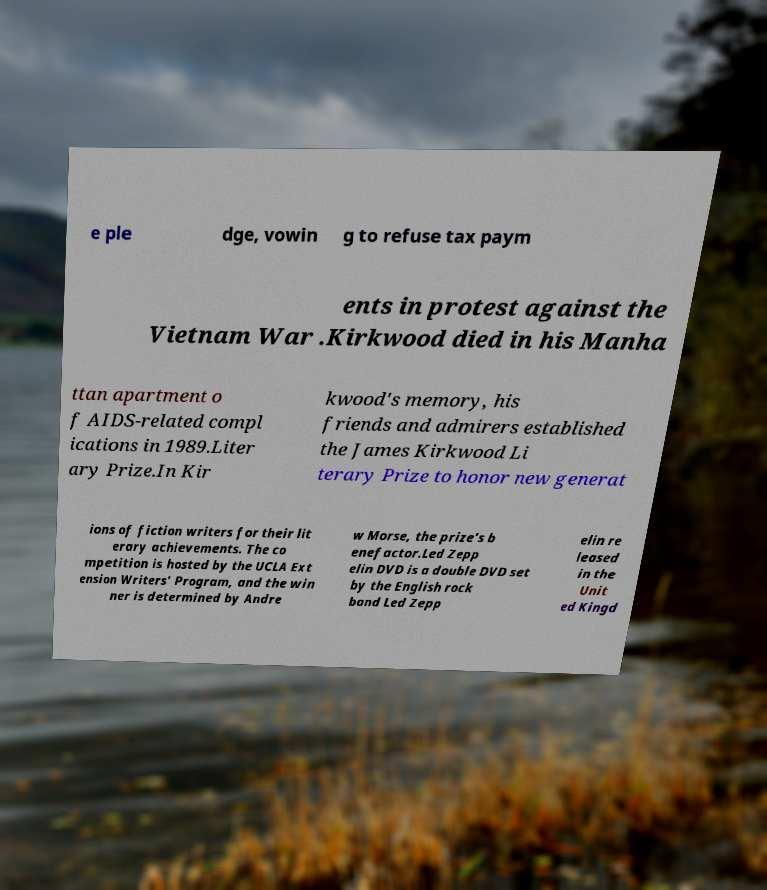Please identify and transcribe the text found in this image. e ple dge, vowin g to refuse tax paym ents in protest against the Vietnam War .Kirkwood died in his Manha ttan apartment o f AIDS-related compl ications in 1989.Liter ary Prize.In Kir kwood's memory, his friends and admirers established the James Kirkwood Li terary Prize to honor new generat ions of fiction writers for their lit erary achievements. The co mpetition is hosted by the UCLA Ext ension Writers' Program, and the win ner is determined by Andre w Morse, the prize's b enefactor.Led Zepp elin DVD is a double DVD set by the English rock band Led Zepp elin re leased in the Unit ed Kingd 